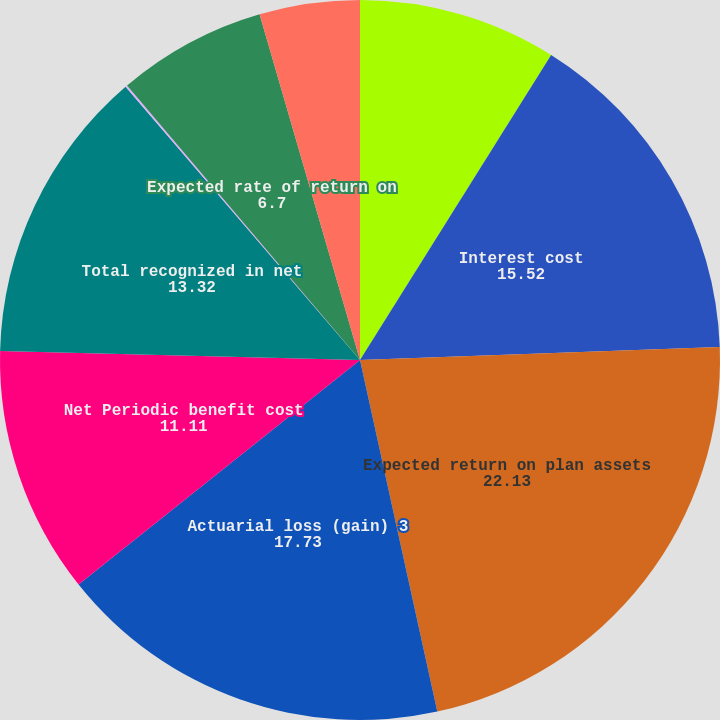<chart> <loc_0><loc_0><loc_500><loc_500><pie_chart><fcel>Service cost<fcel>Interest cost<fcel>Expected return on plan assets<fcel>Actuarial loss (gain) 3<fcel>Net Periodic benefit cost<fcel>Total recognized in net<fcel>Discount rate used to measure<fcel>Expected rate of return on<fcel>Rate of compensation increase<nl><fcel>8.91%<fcel>15.52%<fcel>22.13%<fcel>17.73%<fcel>11.11%<fcel>13.32%<fcel>0.09%<fcel>6.7%<fcel>4.5%<nl></chart> 